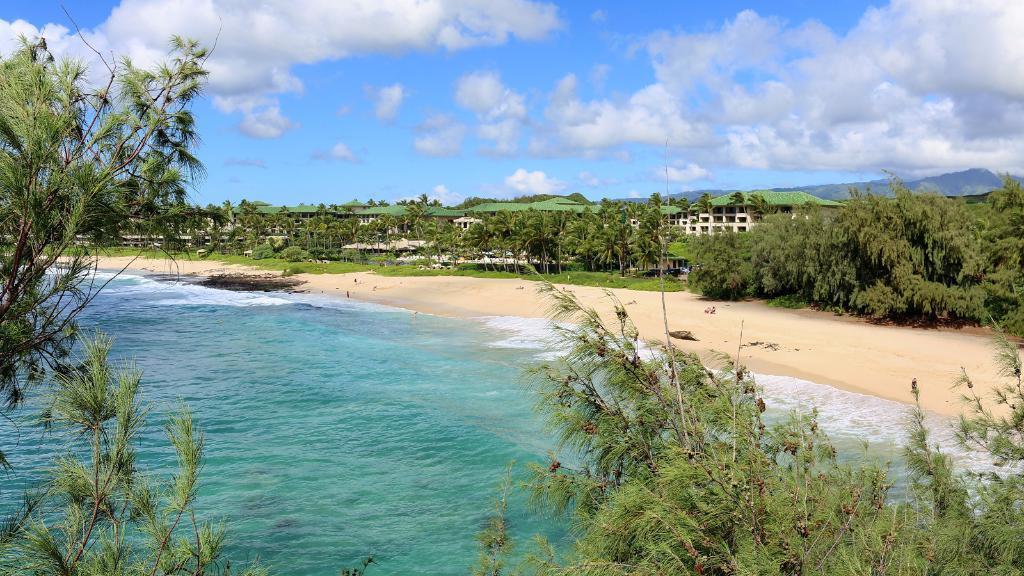Can you describe this image briefly? In this image I can see a beach, water, number of trees, few buildings, clouds and the sky. 